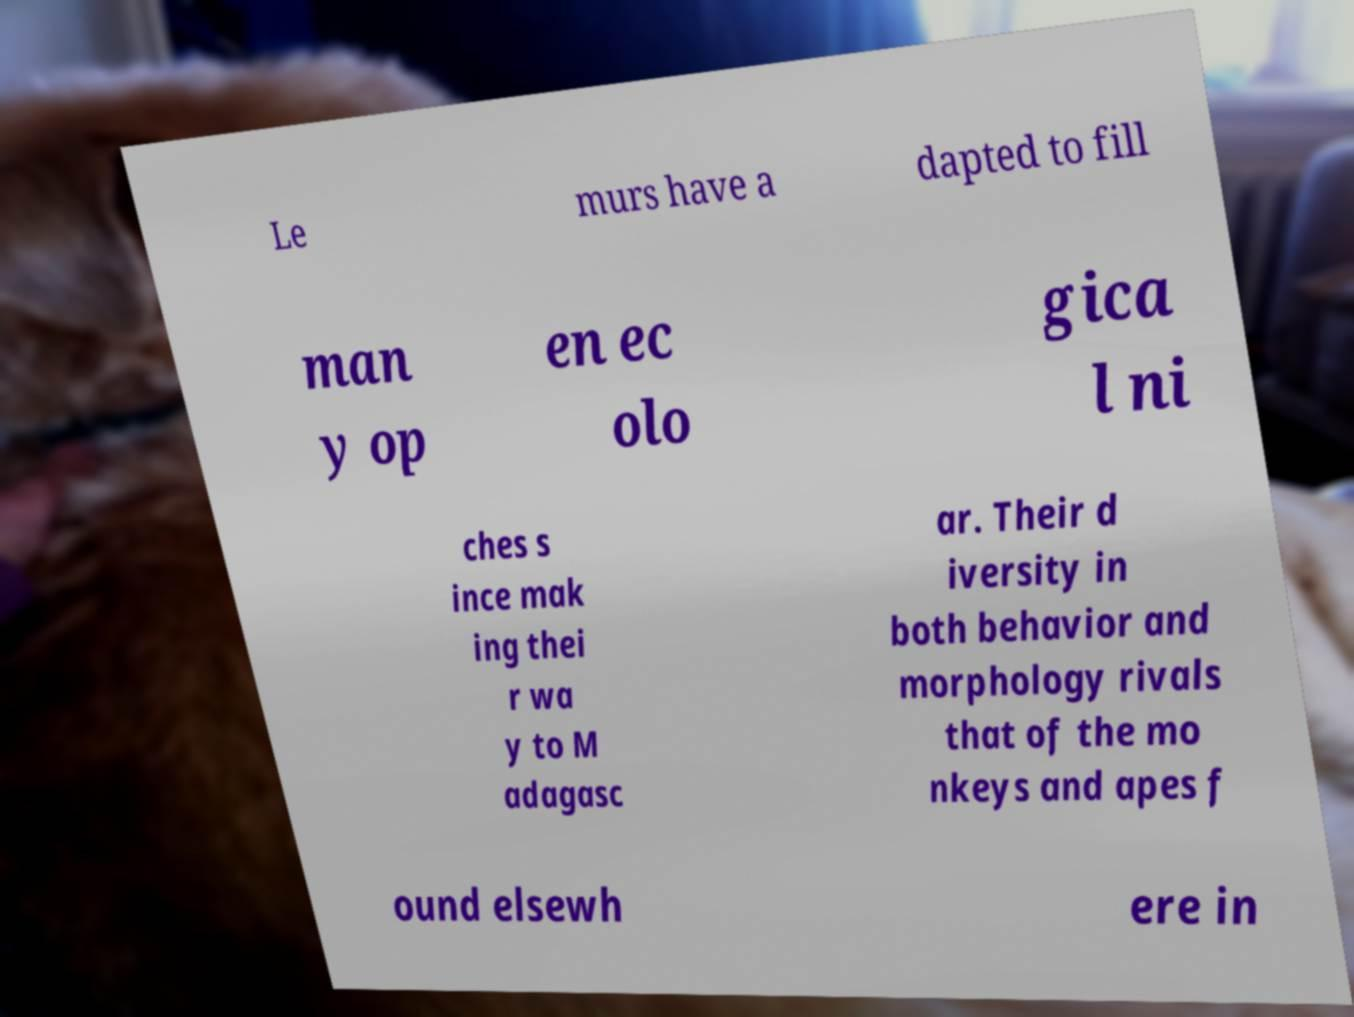Can you read and provide the text displayed in the image?This photo seems to have some interesting text. Can you extract and type it out for me? Le murs have a dapted to fill man y op en ec olo gica l ni ches s ince mak ing thei r wa y to M adagasc ar. Their d iversity in both behavior and morphology rivals that of the mo nkeys and apes f ound elsewh ere in 